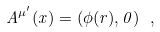<formula> <loc_0><loc_0><loc_500><loc_500>A ^ { \mu ^ { \prime } } ( x ) = ( \phi ( r ) , { 0 } ) \ ,</formula> 